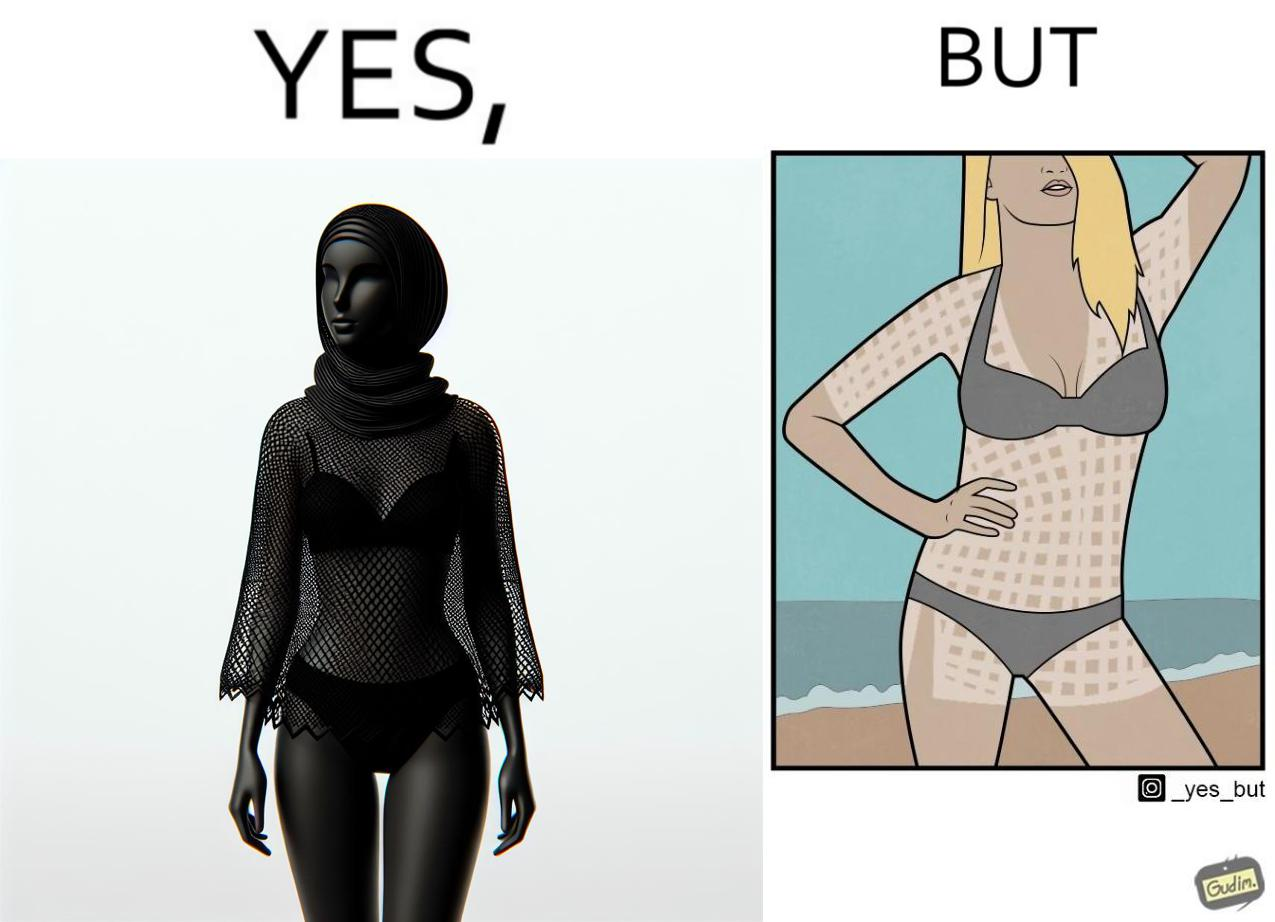Does this image contain satire or humor? Yes, this image is satirical. 